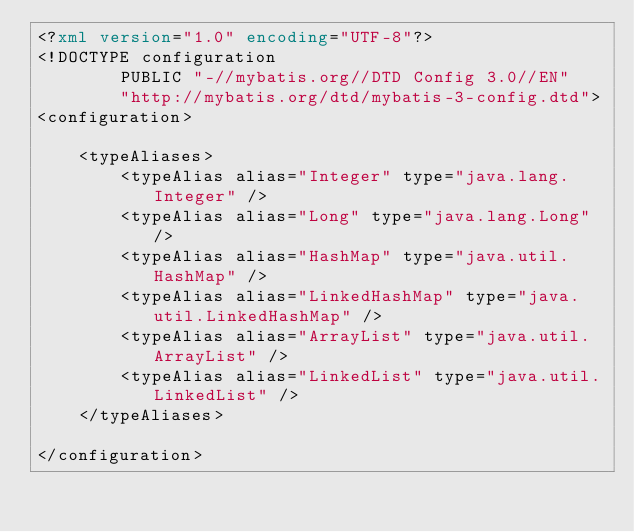Convert code to text. <code><loc_0><loc_0><loc_500><loc_500><_XML_><?xml version="1.0" encoding="UTF-8"?>
<!DOCTYPE configuration
        PUBLIC "-//mybatis.org//DTD Config 3.0//EN"
        "http://mybatis.org/dtd/mybatis-3-config.dtd">
<configuration>

    <typeAliases>
        <typeAlias alias="Integer" type="java.lang.Integer" />
        <typeAlias alias="Long" type="java.lang.Long" />
        <typeAlias alias="HashMap" type="java.util.HashMap" />
        <typeAlias alias="LinkedHashMap" type="java.util.LinkedHashMap" />
        <typeAlias alias="ArrayList" type="java.util.ArrayList" />
        <typeAlias alias="LinkedList" type="java.util.LinkedList" />
    </typeAliases>

</configuration></code> 